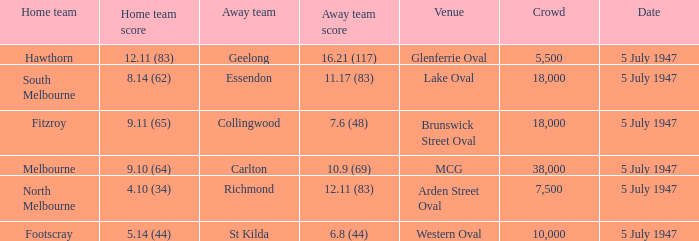What home team played an away team with a score of 6.8 (44)? Footscray. 